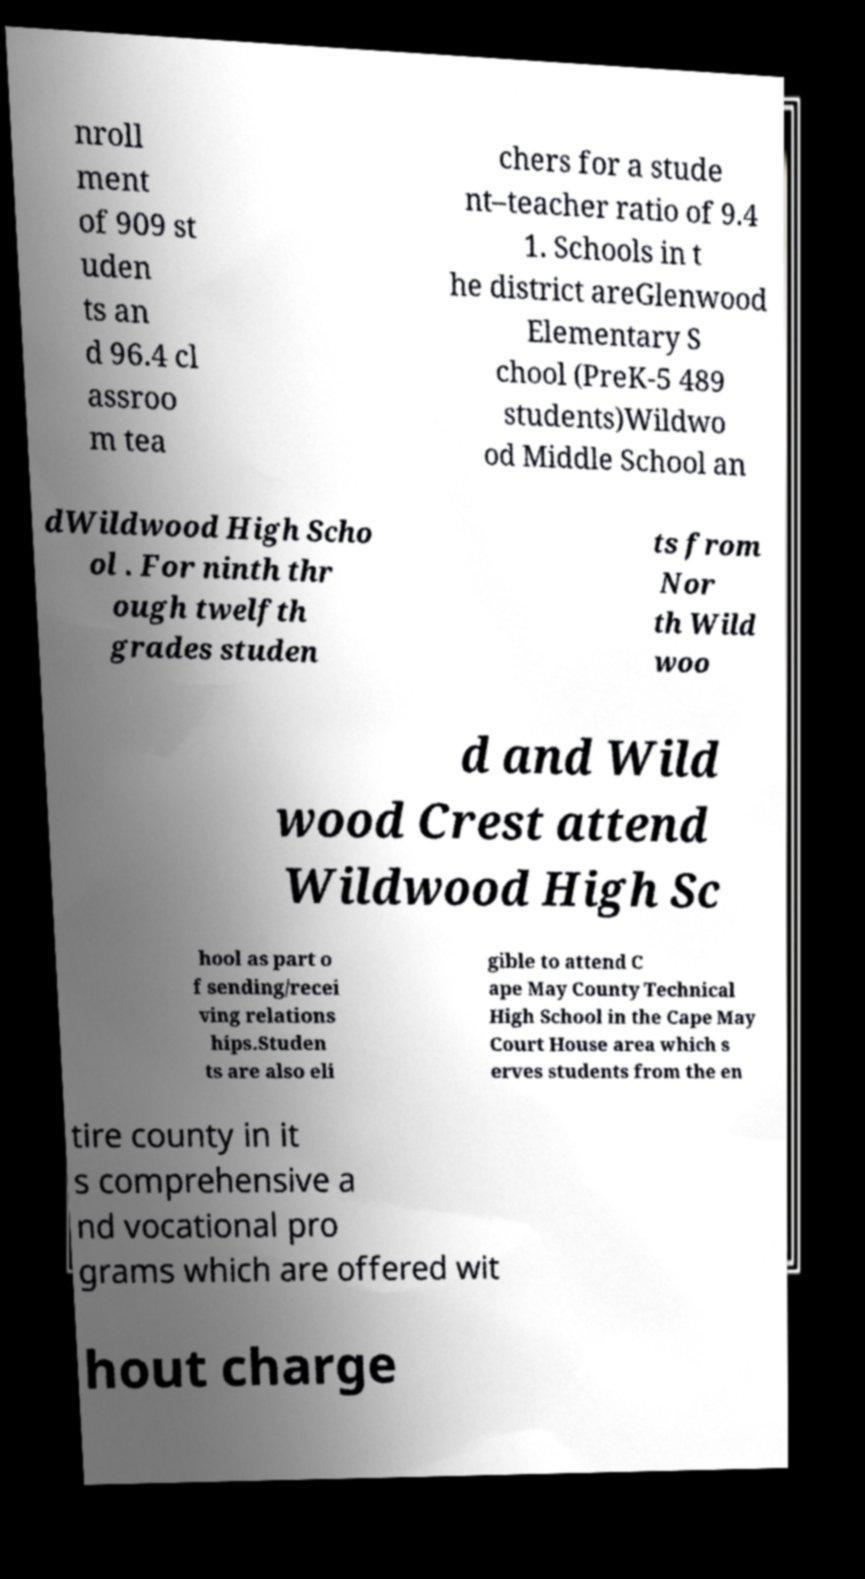Can you read and provide the text displayed in the image?This photo seems to have some interesting text. Can you extract and type it out for me? nroll ment of 909 st uden ts an d 96.4 cl assroo m tea chers for a stude nt–teacher ratio of 9.4 1. Schools in t he district areGlenwood Elementary S chool (PreK-5 489 students)Wildwo od Middle School an dWildwood High Scho ol . For ninth thr ough twelfth grades studen ts from Nor th Wild woo d and Wild wood Crest attend Wildwood High Sc hool as part o f sending/recei ving relations hips.Studen ts are also eli gible to attend C ape May County Technical High School in the Cape May Court House area which s erves students from the en tire county in it s comprehensive a nd vocational pro grams which are offered wit hout charge 